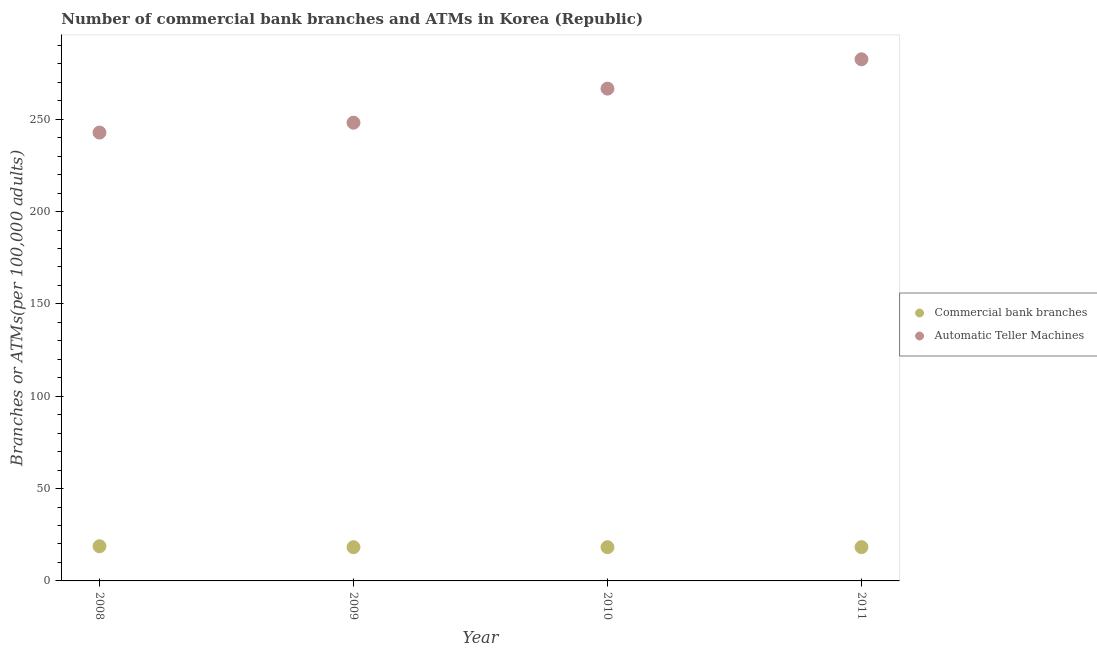How many different coloured dotlines are there?
Make the answer very short. 2. Is the number of dotlines equal to the number of legend labels?
Offer a very short reply. Yes. What is the number of commercal bank branches in 2010?
Your answer should be compact. 18.26. Across all years, what is the maximum number of atms?
Provide a succinct answer. 282.49. Across all years, what is the minimum number of atms?
Provide a short and direct response. 242.79. In which year was the number of atms maximum?
Your answer should be very brief. 2011. What is the total number of atms in the graph?
Your response must be concise. 1040.03. What is the difference between the number of commercal bank branches in 2010 and that in 2011?
Make the answer very short. -0.04. What is the difference between the number of commercal bank branches in 2011 and the number of atms in 2009?
Your answer should be very brief. -229.85. What is the average number of atms per year?
Your response must be concise. 260.01. In the year 2009, what is the difference between the number of atms and number of commercal bank branches?
Keep it short and to the point. 229.88. In how many years, is the number of commercal bank branches greater than 100?
Ensure brevity in your answer.  0. What is the ratio of the number of commercal bank branches in 2009 to that in 2010?
Offer a terse response. 1. Is the number of commercal bank branches in 2008 less than that in 2010?
Make the answer very short. No. Is the difference between the number of commercal bank branches in 2008 and 2011 greater than the difference between the number of atms in 2008 and 2011?
Provide a succinct answer. Yes. What is the difference between the highest and the second highest number of commercal bank branches?
Ensure brevity in your answer.  0.47. What is the difference between the highest and the lowest number of atms?
Offer a very short reply. 39.7. In how many years, is the number of atms greater than the average number of atms taken over all years?
Ensure brevity in your answer.  2. Is the sum of the number of atms in 2009 and 2010 greater than the maximum number of commercal bank branches across all years?
Provide a short and direct response. Yes. Is the number of commercal bank branches strictly less than the number of atms over the years?
Keep it short and to the point. Yes. How many years are there in the graph?
Provide a short and direct response. 4. Are the values on the major ticks of Y-axis written in scientific E-notation?
Give a very brief answer. No. Does the graph contain any zero values?
Make the answer very short. No. How many legend labels are there?
Make the answer very short. 2. What is the title of the graph?
Make the answer very short. Number of commercial bank branches and ATMs in Korea (Republic). Does "By country of origin" appear as one of the legend labels in the graph?
Ensure brevity in your answer.  No. What is the label or title of the X-axis?
Give a very brief answer. Year. What is the label or title of the Y-axis?
Ensure brevity in your answer.  Branches or ATMs(per 100,0 adults). What is the Branches or ATMs(per 100,000 adults) of Commercial bank branches in 2008?
Offer a terse response. 18.77. What is the Branches or ATMs(per 100,000 adults) in Automatic Teller Machines in 2008?
Offer a very short reply. 242.79. What is the Branches or ATMs(per 100,000 adults) in Commercial bank branches in 2009?
Your answer should be very brief. 18.27. What is the Branches or ATMs(per 100,000 adults) of Automatic Teller Machines in 2009?
Provide a short and direct response. 248.15. What is the Branches or ATMs(per 100,000 adults) in Commercial bank branches in 2010?
Your response must be concise. 18.26. What is the Branches or ATMs(per 100,000 adults) in Automatic Teller Machines in 2010?
Offer a very short reply. 266.59. What is the Branches or ATMs(per 100,000 adults) in Commercial bank branches in 2011?
Your response must be concise. 18.3. What is the Branches or ATMs(per 100,000 adults) in Automatic Teller Machines in 2011?
Offer a very short reply. 282.49. Across all years, what is the maximum Branches or ATMs(per 100,000 adults) in Commercial bank branches?
Offer a very short reply. 18.77. Across all years, what is the maximum Branches or ATMs(per 100,000 adults) of Automatic Teller Machines?
Your response must be concise. 282.49. Across all years, what is the minimum Branches or ATMs(per 100,000 adults) of Commercial bank branches?
Your answer should be compact. 18.26. Across all years, what is the minimum Branches or ATMs(per 100,000 adults) of Automatic Teller Machines?
Provide a short and direct response. 242.79. What is the total Branches or ATMs(per 100,000 adults) in Commercial bank branches in the graph?
Make the answer very short. 73.61. What is the total Branches or ATMs(per 100,000 adults) of Automatic Teller Machines in the graph?
Ensure brevity in your answer.  1040.03. What is the difference between the Branches or ATMs(per 100,000 adults) in Commercial bank branches in 2008 and that in 2009?
Make the answer very short. 0.5. What is the difference between the Branches or ATMs(per 100,000 adults) in Automatic Teller Machines in 2008 and that in 2009?
Give a very brief answer. -5.35. What is the difference between the Branches or ATMs(per 100,000 adults) of Commercial bank branches in 2008 and that in 2010?
Your response must be concise. 0.51. What is the difference between the Branches or ATMs(per 100,000 adults) of Automatic Teller Machines in 2008 and that in 2010?
Ensure brevity in your answer.  -23.8. What is the difference between the Branches or ATMs(per 100,000 adults) of Commercial bank branches in 2008 and that in 2011?
Your response must be concise. 0.47. What is the difference between the Branches or ATMs(per 100,000 adults) in Automatic Teller Machines in 2008 and that in 2011?
Your answer should be compact. -39.7. What is the difference between the Branches or ATMs(per 100,000 adults) in Commercial bank branches in 2009 and that in 2010?
Offer a terse response. 0.01. What is the difference between the Branches or ATMs(per 100,000 adults) in Automatic Teller Machines in 2009 and that in 2010?
Provide a short and direct response. -18.45. What is the difference between the Branches or ATMs(per 100,000 adults) in Commercial bank branches in 2009 and that in 2011?
Keep it short and to the point. -0.03. What is the difference between the Branches or ATMs(per 100,000 adults) in Automatic Teller Machines in 2009 and that in 2011?
Your answer should be very brief. -34.34. What is the difference between the Branches or ATMs(per 100,000 adults) of Commercial bank branches in 2010 and that in 2011?
Provide a succinct answer. -0.04. What is the difference between the Branches or ATMs(per 100,000 adults) of Automatic Teller Machines in 2010 and that in 2011?
Your answer should be compact. -15.9. What is the difference between the Branches or ATMs(per 100,000 adults) in Commercial bank branches in 2008 and the Branches or ATMs(per 100,000 adults) in Automatic Teller Machines in 2009?
Provide a succinct answer. -229.37. What is the difference between the Branches or ATMs(per 100,000 adults) in Commercial bank branches in 2008 and the Branches or ATMs(per 100,000 adults) in Automatic Teller Machines in 2010?
Ensure brevity in your answer.  -247.82. What is the difference between the Branches or ATMs(per 100,000 adults) of Commercial bank branches in 2008 and the Branches or ATMs(per 100,000 adults) of Automatic Teller Machines in 2011?
Make the answer very short. -263.72. What is the difference between the Branches or ATMs(per 100,000 adults) of Commercial bank branches in 2009 and the Branches or ATMs(per 100,000 adults) of Automatic Teller Machines in 2010?
Make the answer very short. -248.32. What is the difference between the Branches or ATMs(per 100,000 adults) of Commercial bank branches in 2009 and the Branches or ATMs(per 100,000 adults) of Automatic Teller Machines in 2011?
Make the answer very short. -264.22. What is the difference between the Branches or ATMs(per 100,000 adults) in Commercial bank branches in 2010 and the Branches or ATMs(per 100,000 adults) in Automatic Teller Machines in 2011?
Ensure brevity in your answer.  -264.23. What is the average Branches or ATMs(per 100,000 adults) of Commercial bank branches per year?
Make the answer very short. 18.4. What is the average Branches or ATMs(per 100,000 adults) in Automatic Teller Machines per year?
Ensure brevity in your answer.  260.01. In the year 2008, what is the difference between the Branches or ATMs(per 100,000 adults) in Commercial bank branches and Branches or ATMs(per 100,000 adults) in Automatic Teller Machines?
Provide a short and direct response. -224.02. In the year 2009, what is the difference between the Branches or ATMs(per 100,000 adults) of Commercial bank branches and Branches or ATMs(per 100,000 adults) of Automatic Teller Machines?
Your answer should be very brief. -229.88. In the year 2010, what is the difference between the Branches or ATMs(per 100,000 adults) of Commercial bank branches and Branches or ATMs(per 100,000 adults) of Automatic Teller Machines?
Offer a terse response. -248.33. In the year 2011, what is the difference between the Branches or ATMs(per 100,000 adults) of Commercial bank branches and Branches or ATMs(per 100,000 adults) of Automatic Teller Machines?
Offer a very short reply. -264.19. What is the ratio of the Branches or ATMs(per 100,000 adults) of Commercial bank branches in 2008 to that in 2009?
Provide a succinct answer. 1.03. What is the ratio of the Branches or ATMs(per 100,000 adults) in Automatic Teller Machines in 2008 to that in 2009?
Keep it short and to the point. 0.98. What is the ratio of the Branches or ATMs(per 100,000 adults) in Commercial bank branches in 2008 to that in 2010?
Make the answer very short. 1.03. What is the ratio of the Branches or ATMs(per 100,000 adults) in Automatic Teller Machines in 2008 to that in 2010?
Provide a succinct answer. 0.91. What is the ratio of the Branches or ATMs(per 100,000 adults) of Commercial bank branches in 2008 to that in 2011?
Provide a succinct answer. 1.03. What is the ratio of the Branches or ATMs(per 100,000 adults) in Automatic Teller Machines in 2008 to that in 2011?
Ensure brevity in your answer.  0.86. What is the ratio of the Branches or ATMs(per 100,000 adults) in Automatic Teller Machines in 2009 to that in 2010?
Make the answer very short. 0.93. What is the ratio of the Branches or ATMs(per 100,000 adults) of Automatic Teller Machines in 2009 to that in 2011?
Your response must be concise. 0.88. What is the ratio of the Branches or ATMs(per 100,000 adults) of Automatic Teller Machines in 2010 to that in 2011?
Keep it short and to the point. 0.94. What is the difference between the highest and the second highest Branches or ATMs(per 100,000 adults) in Commercial bank branches?
Offer a terse response. 0.47. What is the difference between the highest and the second highest Branches or ATMs(per 100,000 adults) in Automatic Teller Machines?
Ensure brevity in your answer.  15.9. What is the difference between the highest and the lowest Branches or ATMs(per 100,000 adults) in Commercial bank branches?
Make the answer very short. 0.51. What is the difference between the highest and the lowest Branches or ATMs(per 100,000 adults) in Automatic Teller Machines?
Provide a short and direct response. 39.7. 